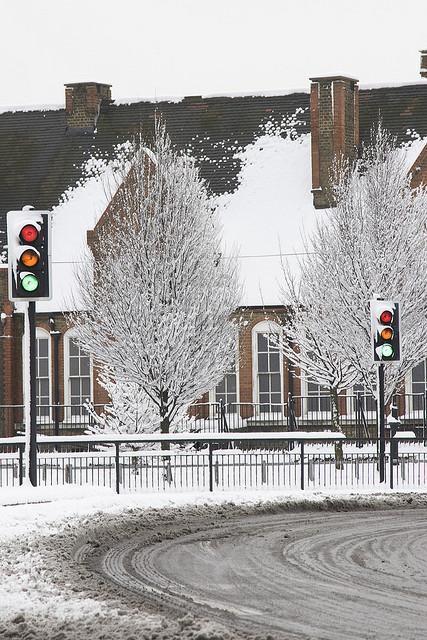How many people are wearing a pink shirt?
Give a very brief answer. 0. 